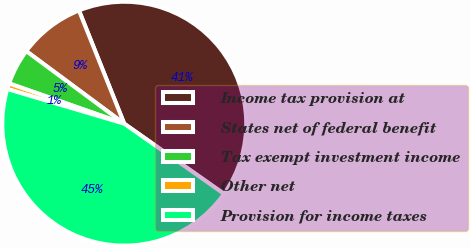Convert chart. <chart><loc_0><loc_0><loc_500><loc_500><pie_chart><fcel>Income tax provision at<fcel>States net of federal benefit<fcel>Tax exempt investment income<fcel>Other net<fcel>Provision for income taxes<nl><fcel>40.81%<fcel>8.8%<fcel>4.79%<fcel>0.77%<fcel>44.83%<nl></chart> 